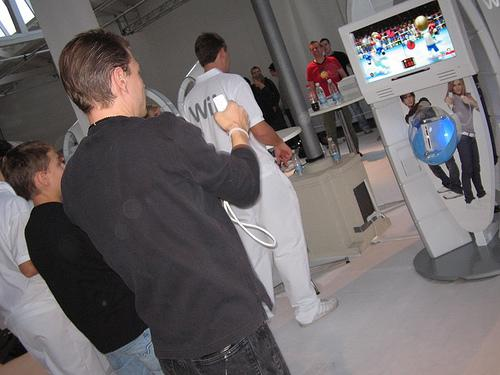Question: what gaming system is being used?
Choices:
A. Ps2.
B. Ps3.
C. A computer.
D. Wii.
Answer with the letter. Answer: D Question: what sport is being played in the game?
Choices:
A. Fencing.
B. Football.
C. Baseball.
D. Boxing.
Answer with the letter. Answer: D Question: who is holding the gaming remote?
Choices:
A. The man in the red shirt.
B. The man in the green shirt.
C. The man in the blue shirt.
D. The man in the grey shirt.
Answer with the letter. Answer: D Question: how is the man in the grey shirt keeping the gaming remote from falling off?
Choices:
A. With tape.
B. With a wrist strap.
C. With a magnet.
D. With a string.
Answer with the letter. Answer: B Question: what is on the tables in the center?
Choices:
A. Cups.
B. Water bottles.
C. Snacks.
D. Forks.
Answer with the letter. Answer: B 